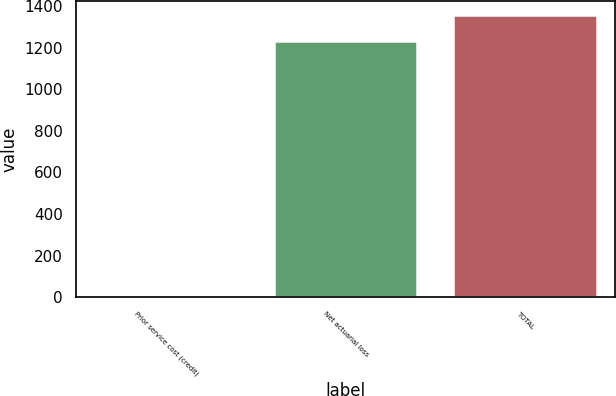<chart> <loc_0><loc_0><loc_500><loc_500><bar_chart><fcel>Prior service cost (credit)<fcel>Net actuarial loss<fcel>TOTAL<nl><fcel>4.9<fcel>1235.1<fcel>1358.61<nl></chart> 